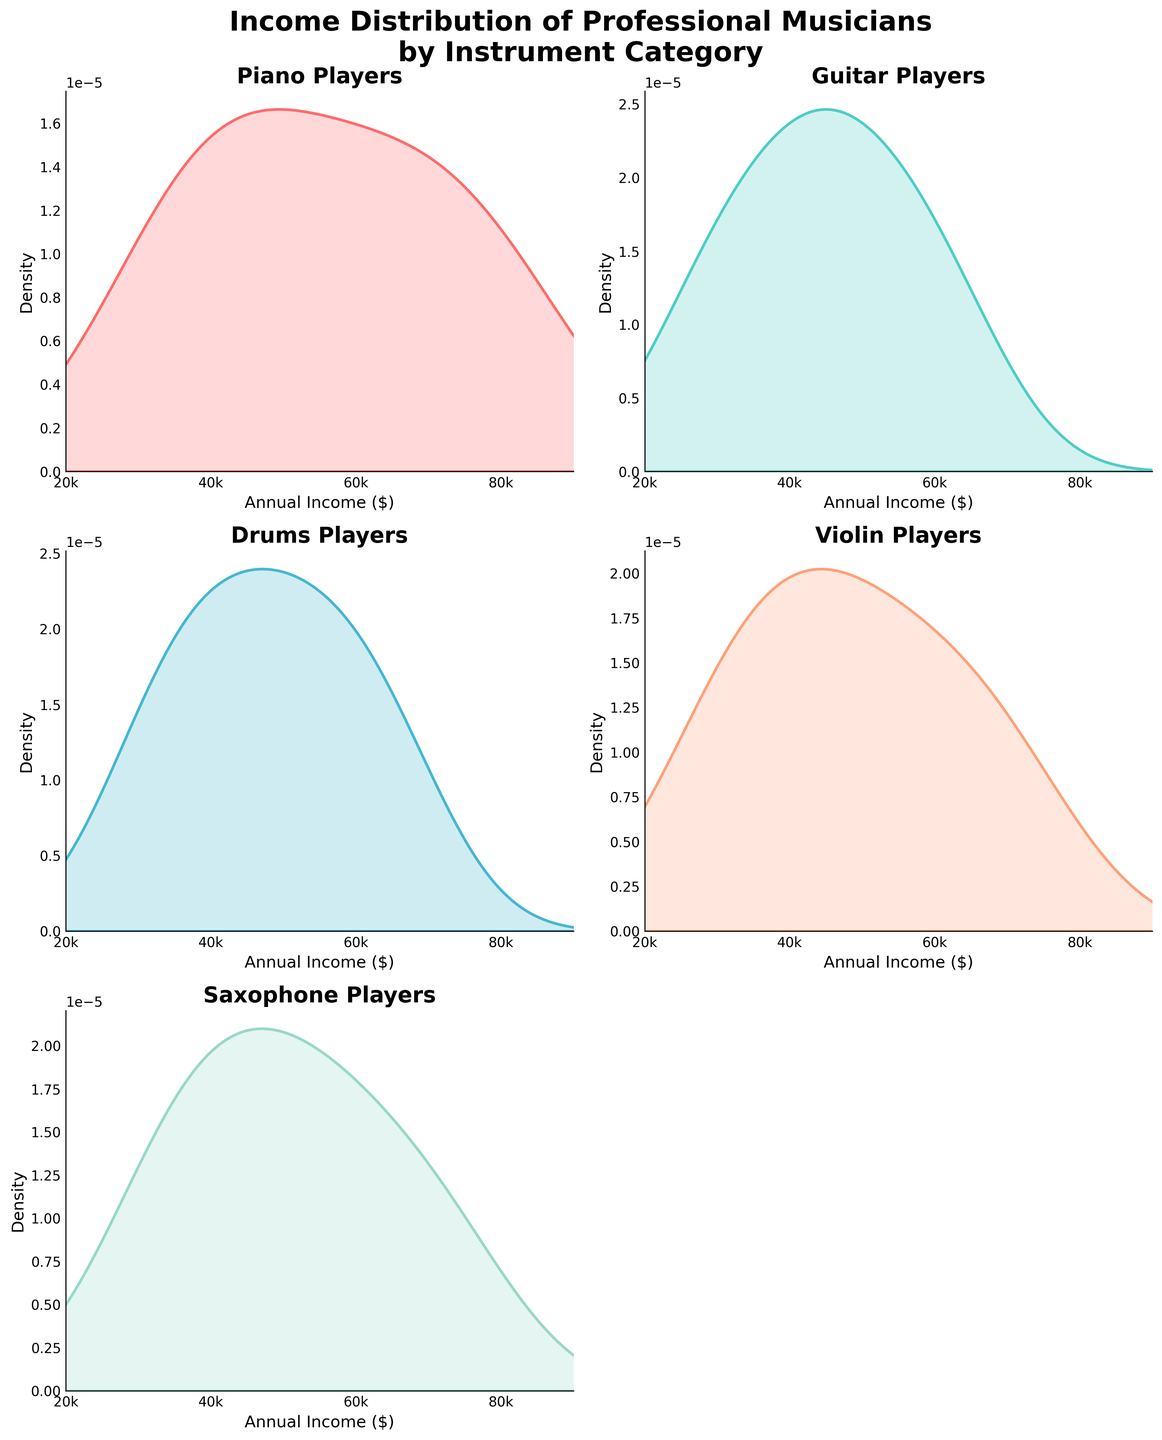What is the title of the figure? The title of the figure is usually displayed at the top and serves to describe the content of the plots. In this case, the title reads, "Income Distribution of Professional Musicians by Instrument Category".
Answer: Income Distribution of Professional Musicians by Instrument Category Which instrument category has its density plot represented in red? The legend or the distinct fill colors of each subplot can help identify the instruments. The color red is used for piano players.
Answer: Piano What is the range of annual income displayed on the x-axis for each subplot? The x-axis of each subplot shows the annual income range, which spans from 20000 to 90000 dollars. These ranges can be observed from the x-axis tick marks and the plot limits.
Answer: 20000 to 90000 Which instrument has the highest density peak for income above $60,000? By inspecting the height of the density peaks for incomes above $60,000, we observe that the Piano and Violin densities reach notable heights; the highest peak seems to belong to the Piano.
Answer: Piano Which instrument's density plot is missing from the third row, second column? Observing the subplot layout, the third row, second column subplot is empty or turned off, indicating no density plot is displayed there.
Answer: None Which instrument has the most compact income distribution? A compact distribution appears as a narrow density peak. By comparing the width of the peaks, the Guitar's income distribution seems to be the most compact.
Answer: Guitar Compare the income distributions of Drums and Violin players. Which group appears to have a broader income range? A broader income range will show a wider density plot along the x-axis. Comparing the width of the density plots, Violin players have a slightly broader income range than Drums players.
Answer: Violin Is there any subplot without a title? By examining each subplot's title area, we identify that none of the density plots are missing titles; each indicates the instrument being plotted.
Answer: No How does the median income for Piano players compare to that of Guitar players? The median income is located around the peak of each density plot. The peak for Guitar players appears around $45,000, while for Piano players, it is around $55,000. Therefore, Piano players have a higher median income.
Answer: Piano players have a higher median income If a musician earns $40,000 annually, which instrument's players are they most likely to encounter at this income level? To determine this, look for the density plot where $40,000 falls near the peak. Guitar players have a peak of high density around the $40,000 mark compared to others.
Answer: Guitar 